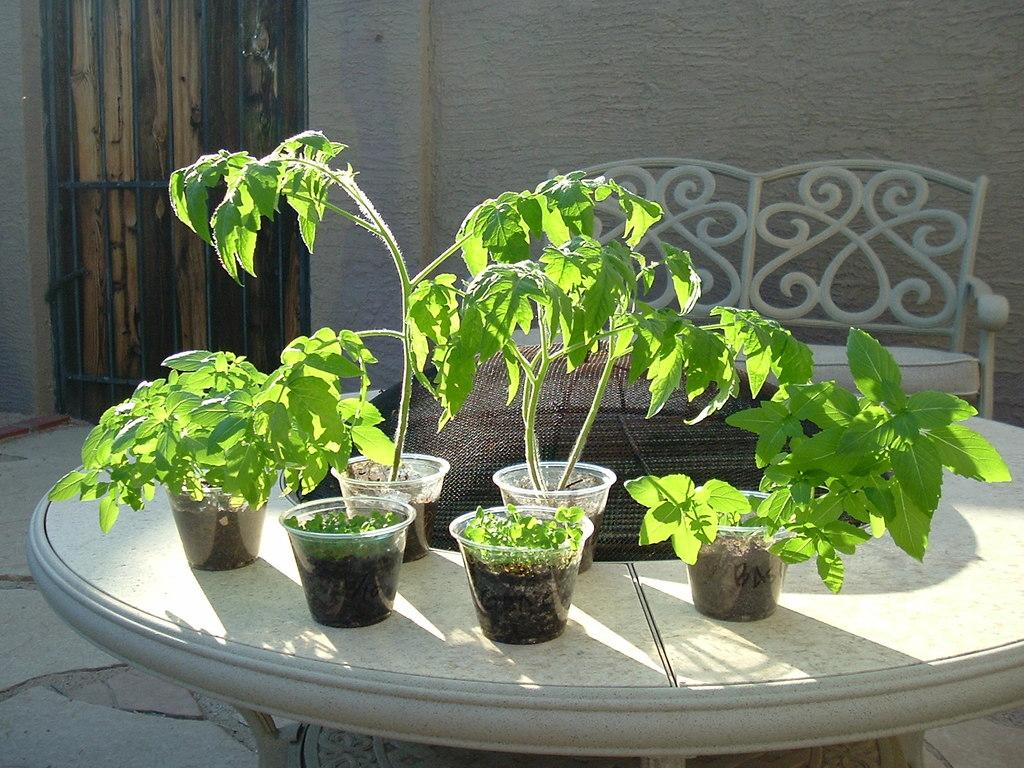What type of plants are in the image? There are potted plants in the image. Where are the potted plants located? The potted plants are on a table. What part of the room can be seen in the image? The floor is visible in the image. What furniture can be seen in the background of the image? There is a chair in the background of the image. What architectural feature is on the left side of the image? There is a wooden door on the left side of the image. How many dogs are sitting on the chair in the image? There are no dogs present in the image; it only features potted plants, a table, a floor, a chair, and a wooden door. 